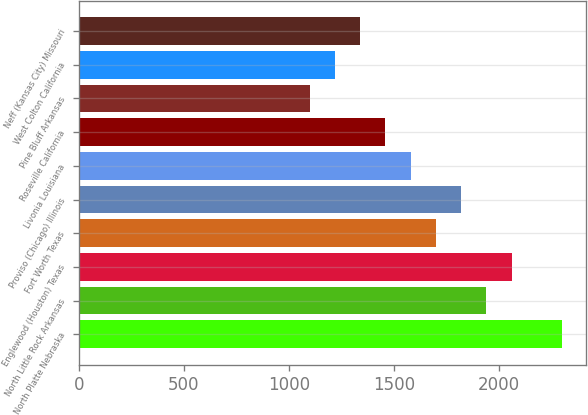<chart> <loc_0><loc_0><loc_500><loc_500><bar_chart><fcel>North Platte Nebraska<fcel>North Little Rock Arkansas<fcel>Englewood (Houston) Texas<fcel>Fort Worth Texas<fcel>Proviso (Chicago) Illinois<fcel>Livonia Louisiana<fcel>Roseville California<fcel>Pine Bluff Arkansas<fcel>West Colton California<fcel>Neff (Kansas City) Missouri<nl><fcel>2300<fcel>1940<fcel>2060<fcel>1700<fcel>1820<fcel>1580<fcel>1460<fcel>1100<fcel>1220<fcel>1340<nl></chart> 